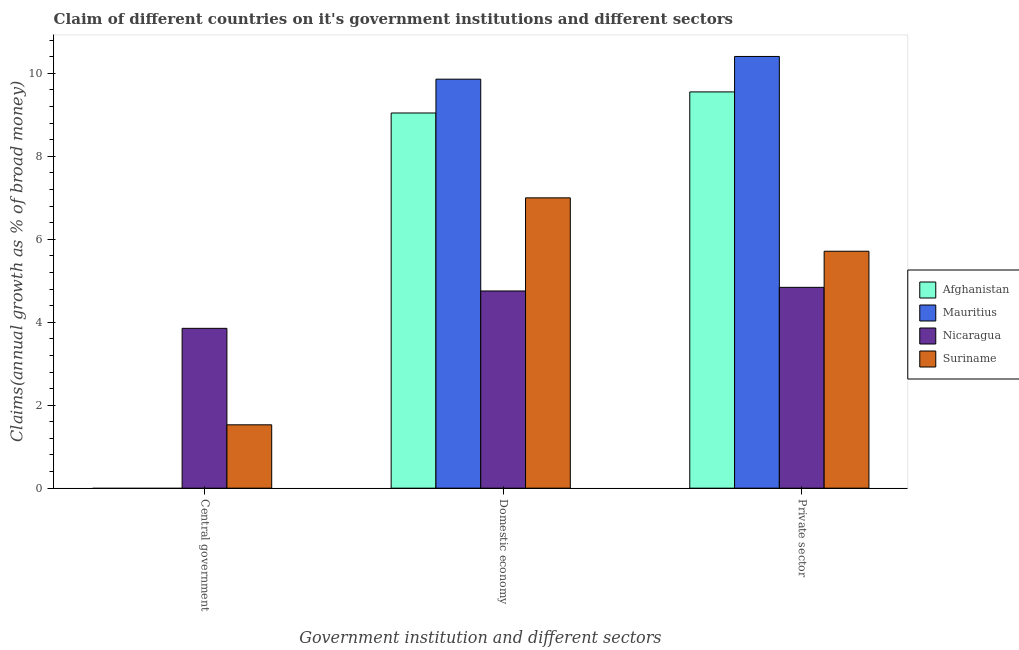How many groups of bars are there?
Offer a very short reply. 3. How many bars are there on the 1st tick from the left?
Your answer should be compact. 2. How many bars are there on the 1st tick from the right?
Make the answer very short. 4. What is the label of the 2nd group of bars from the left?
Provide a short and direct response. Domestic economy. What is the percentage of claim on the domestic economy in Mauritius?
Your response must be concise. 9.86. Across all countries, what is the maximum percentage of claim on the domestic economy?
Your answer should be compact. 9.86. Across all countries, what is the minimum percentage of claim on the domestic economy?
Provide a succinct answer. 4.75. In which country was the percentage of claim on the private sector maximum?
Offer a very short reply. Mauritius. What is the total percentage of claim on the private sector in the graph?
Provide a succinct answer. 30.51. What is the difference between the percentage of claim on the domestic economy in Suriname and that in Nicaragua?
Provide a short and direct response. 2.25. What is the difference between the percentage of claim on the central government in Nicaragua and the percentage of claim on the domestic economy in Afghanistan?
Ensure brevity in your answer.  -5.19. What is the average percentage of claim on the domestic economy per country?
Your response must be concise. 7.66. What is the difference between the percentage of claim on the central government and percentage of claim on the domestic economy in Nicaragua?
Your response must be concise. -0.9. What is the ratio of the percentage of claim on the central government in Nicaragua to that in Suriname?
Offer a terse response. 2.52. What is the difference between the highest and the second highest percentage of claim on the domestic economy?
Offer a very short reply. 0.82. What is the difference between the highest and the lowest percentage of claim on the central government?
Provide a succinct answer. 3.85. Is the sum of the percentage of claim on the private sector in Nicaragua and Afghanistan greater than the maximum percentage of claim on the domestic economy across all countries?
Your answer should be compact. Yes. Is it the case that in every country, the sum of the percentage of claim on the central government and percentage of claim on the domestic economy is greater than the percentage of claim on the private sector?
Give a very brief answer. No. Are all the bars in the graph horizontal?
Your answer should be very brief. No. Are the values on the major ticks of Y-axis written in scientific E-notation?
Your answer should be compact. No. Does the graph contain any zero values?
Offer a terse response. Yes. How many legend labels are there?
Give a very brief answer. 4. How are the legend labels stacked?
Your answer should be very brief. Vertical. What is the title of the graph?
Offer a very short reply. Claim of different countries on it's government institutions and different sectors. Does "Somalia" appear as one of the legend labels in the graph?
Provide a short and direct response. No. What is the label or title of the X-axis?
Provide a short and direct response. Government institution and different sectors. What is the label or title of the Y-axis?
Keep it short and to the point. Claims(annual growth as % of broad money). What is the Claims(annual growth as % of broad money) in Afghanistan in Central government?
Offer a terse response. 0. What is the Claims(annual growth as % of broad money) in Mauritius in Central government?
Your response must be concise. 0. What is the Claims(annual growth as % of broad money) in Nicaragua in Central government?
Your response must be concise. 3.85. What is the Claims(annual growth as % of broad money) in Suriname in Central government?
Your response must be concise. 1.53. What is the Claims(annual growth as % of broad money) of Afghanistan in Domestic economy?
Your response must be concise. 9.04. What is the Claims(annual growth as % of broad money) in Mauritius in Domestic economy?
Provide a succinct answer. 9.86. What is the Claims(annual growth as % of broad money) in Nicaragua in Domestic economy?
Offer a terse response. 4.75. What is the Claims(annual growth as % of broad money) of Suriname in Domestic economy?
Offer a very short reply. 7. What is the Claims(annual growth as % of broad money) of Afghanistan in Private sector?
Your response must be concise. 9.55. What is the Claims(annual growth as % of broad money) of Mauritius in Private sector?
Give a very brief answer. 10.41. What is the Claims(annual growth as % of broad money) in Nicaragua in Private sector?
Provide a short and direct response. 4.84. What is the Claims(annual growth as % of broad money) of Suriname in Private sector?
Provide a succinct answer. 5.71. Across all Government institution and different sectors, what is the maximum Claims(annual growth as % of broad money) of Afghanistan?
Ensure brevity in your answer.  9.55. Across all Government institution and different sectors, what is the maximum Claims(annual growth as % of broad money) in Mauritius?
Make the answer very short. 10.41. Across all Government institution and different sectors, what is the maximum Claims(annual growth as % of broad money) of Nicaragua?
Provide a short and direct response. 4.84. Across all Government institution and different sectors, what is the maximum Claims(annual growth as % of broad money) of Suriname?
Offer a terse response. 7. Across all Government institution and different sectors, what is the minimum Claims(annual growth as % of broad money) in Nicaragua?
Offer a very short reply. 3.85. Across all Government institution and different sectors, what is the minimum Claims(annual growth as % of broad money) in Suriname?
Offer a terse response. 1.53. What is the total Claims(annual growth as % of broad money) in Afghanistan in the graph?
Keep it short and to the point. 18.6. What is the total Claims(annual growth as % of broad money) of Mauritius in the graph?
Offer a terse response. 20.27. What is the total Claims(annual growth as % of broad money) of Nicaragua in the graph?
Your response must be concise. 13.45. What is the total Claims(annual growth as % of broad money) in Suriname in the graph?
Your answer should be very brief. 14.24. What is the difference between the Claims(annual growth as % of broad money) of Nicaragua in Central government and that in Domestic economy?
Provide a succinct answer. -0.9. What is the difference between the Claims(annual growth as % of broad money) of Suriname in Central government and that in Domestic economy?
Provide a short and direct response. -5.47. What is the difference between the Claims(annual growth as % of broad money) of Nicaragua in Central government and that in Private sector?
Your answer should be very brief. -0.99. What is the difference between the Claims(annual growth as % of broad money) of Suriname in Central government and that in Private sector?
Offer a very short reply. -4.18. What is the difference between the Claims(annual growth as % of broad money) in Afghanistan in Domestic economy and that in Private sector?
Provide a short and direct response. -0.51. What is the difference between the Claims(annual growth as % of broad money) in Mauritius in Domestic economy and that in Private sector?
Offer a very short reply. -0.55. What is the difference between the Claims(annual growth as % of broad money) of Nicaragua in Domestic economy and that in Private sector?
Provide a short and direct response. -0.09. What is the difference between the Claims(annual growth as % of broad money) of Suriname in Domestic economy and that in Private sector?
Offer a very short reply. 1.29. What is the difference between the Claims(annual growth as % of broad money) of Nicaragua in Central government and the Claims(annual growth as % of broad money) of Suriname in Domestic economy?
Provide a short and direct response. -3.15. What is the difference between the Claims(annual growth as % of broad money) in Nicaragua in Central government and the Claims(annual growth as % of broad money) in Suriname in Private sector?
Your answer should be compact. -1.86. What is the difference between the Claims(annual growth as % of broad money) in Afghanistan in Domestic economy and the Claims(annual growth as % of broad money) in Mauritius in Private sector?
Give a very brief answer. -1.36. What is the difference between the Claims(annual growth as % of broad money) in Afghanistan in Domestic economy and the Claims(annual growth as % of broad money) in Nicaragua in Private sector?
Keep it short and to the point. 4.2. What is the difference between the Claims(annual growth as % of broad money) of Afghanistan in Domestic economy and the Claims(annual growth as % of broad money) of Suriname in Private sector?
Provide a succinct answer. 3.33. What is the difference between the Claims(annual growth as % of broad money) of Mauritius in Domestic economy and the Claims(annual growth as % of broad money) of Nicaragua in Private sector?
Provide a short and direct response. 5.02. What is the difference between the Claims(annual growth as % of broad money) in Mauritius in Domestic economy and the Claims(annual growth as % of broad money) in Suriname in Private sector?
Give a very brief answer. 4.15. What is the difference between the Claims(annual growth as % of broad money) in Nicaragua in Domestic economy and the Claims(annual growth as % of broad money) in Suriname in Private sector?
Give a very brief answer. -0.96. What is the average Claims(annual growth as % of broad money) of Afghanistan per Government institution and different sectors?
Keep it short and to the point. 6.2. What is the average Claims(annual growth as % of broad money) in Mauritius per Government institution and different sectors?
Ensure brevity in your answer.  6.76. What is the average Claims(annual growth as % of broad money) in Nicaragua per Government institution and different sectors?
Ensure brevity in your answer.  4.48. What is the average Claims(annual growth as % of broad money) of Suriname per Government institution and different sectors?
Give a very brief answer. 4.75. What is the difference between the Claims(annual growth as % of broad money) in Nicaragua and Claims(annual growth as % of broad money) in Suriname in Central government?
Offer a very short reply. 2.33. What is the difference between the Claims(annual growth as % of broad money) of Afghanistan and Claims(annual growth as % of broad money) of Mauritius in Domestic economy?
Your answer should be compact. -0.82. What is the difference between the Claims(annual growth as % of broad money) of Afghanistan and Claims(annual growth as % of broad money) of Nicaragua in Domestic economy?
Your answer should be compact. 4.29. What is the difference between the Claims(annual growth as % of broad money) in Afghanistan and Claims(annual growth as % of broad money) in Suriname in Domestic economy?
Ensure brevity in your answer.  2.05. What is the difference between the Claims(annual growth as % of broad money) of Mauritius and Claims(annual growth as % of broad money) of Nicaragua in Domestic economy?
Provide a succinct answer. 5.11. What is the difference between the Claims(annual growth as % of broad money) of Mauritius and Claims(annual growth as % of broad money) of Suriname in Domestic economy?
Offer a very short reply. 2.86. What is the difference between the Claims(annual growth as % of broad money) of Nicaragua and Claims(annual growth as % of broad money) of Suriname in Domestic economy?
Provide a succinct answer. -2.25. What is the difference between the Claims(annual growth as % of broad money) in Afghanistan and Claims(annual growth as % of broad money) in Mauritius in Private sector?
Keep it short and to the point. -0.85. What is the difference between the Claims(annual growth as % of broad money) in Afghanistan and Claims(annual growth as % of broad money) in Nicaragua in Private sector?
Your answer should be compact. 4.71. What is the difference between the Claims(annual growth as % of broad money) in Afghanistan and Claims(annual growth as % of broad money) in Suriname in Private sector?
Keep it short and to the point. 3.84. What is the difference between the Claims(annual growth as % of broad money) in Mauritius and Claims(annual growth as % of broad money) in Nicaragua in Private sector?
Keep it short and to the point. 5.57. What is the difference between the Claims(annual growth as % of broad money) in Mauritius and Claims(annual growth as % of broad money) in Suriname in Private sector?
Make the answer very short. 4.7. What is the difference between the Claims(annual growth as % of broad money) of Nicaragua and Claims(annual growth as % of broad money) of Suriname in Private sector?
Make the answer very short. -0.87. What is the ratio of the Claims(annual growth as % of broad money) in Nicaragua in Central government to that in Domestic economy?
Provide a short and direct response. 0.81. What is the ratio of the Claims(annual growth as % of broad money) in Suriname in Central government to that in Domestic economy?
Provide a succinct answer. 0.22. What is the ratio of the Claims(annual growth as % of broad money) in Nicaragua in Central government to that in Private sector?
Make the answer very short. 0.8. What is the ratio of the Claims(annual growth as % of broad money) of Suriname in Central government to that in Private sector?
Your response must be concise. 0.27. What is the ratio of the Claims(annual growth as % of broad money) of Afghanistan in Domestic economy to that in Private sector?
Make the answer very short. 0.95. What is the ratio of the Claims(annual growth as % of broad money) in Mauritius in Domestic economy to that in Private sector?
Give a very brief answer. 0.95. What is the ratio of the Claims(annual growth as % of broad money) in Nicaragua in Domestic economy to that in Private sector?
Ensure brevity in your answer.  0.98. What is the ratio of the Claims(annual growth as % of broad money) in Suriname in Domestic economy to that in Private sector?
Provide a succinct answer. 1.23. What is the difference between the highest and the second highest Claims(annual growth as % of broad money) in Nicaragua?
Ensure brevity in your answer.  0.09. What is the difference between the highest and the second highest Claims(annual growth as % of broad money) in Suriname?
Give a very brief answer. 1.29. What is the difference between the highest and the lowest Claims(annual growth as % of broad money) of Afghanistan?
Offer a terse response. 9.55. What is the difference between the highest and the lowest Claims(annual growth as % of broad money) of Mauritius?
Ensure brevity in your answer.  10.41. What is the difference between the highest and the lowest Claims(annual growth as % of broad money) in Nicaragua?
Offer a very short reply. 0.99. What is the difference between the highest and the lowest Claims(annual growth as % of broad money) of Suriname?
Ensure brevity in your answer.  5.47. 